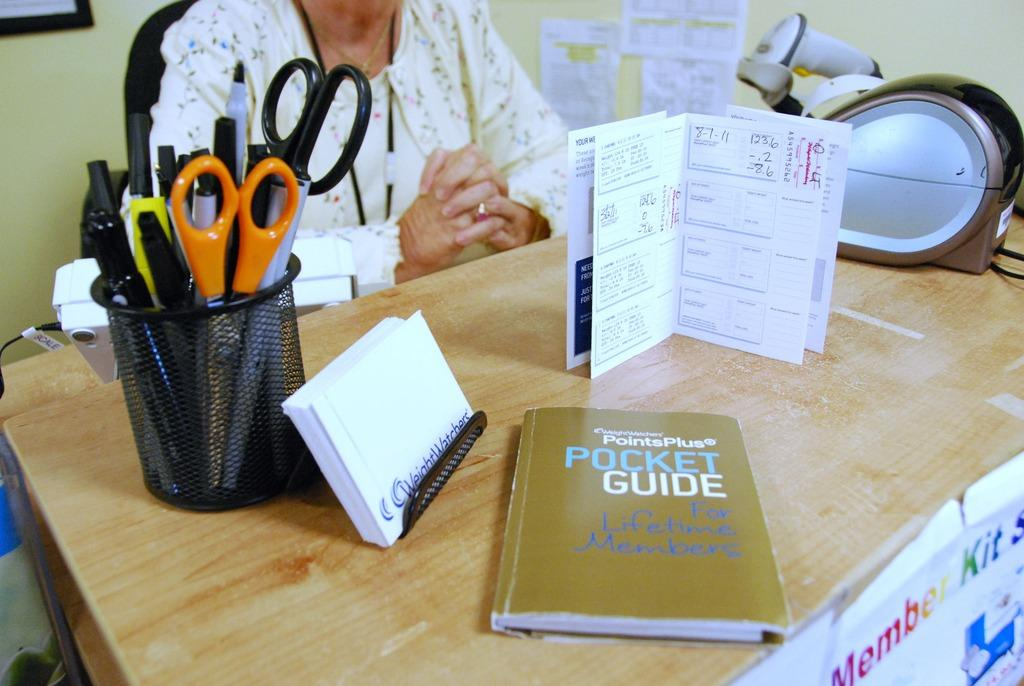<image>
Offer a succinct explanation of the picture presented. A book for the PointsPlus Pocket Guide sits on a brown table with office supplies. 